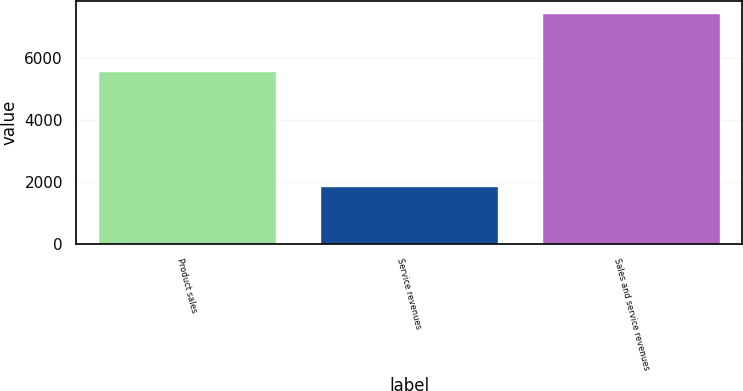<chart> <loc_0><loc_0><loc_500><loc_500><bar_chart><fcel>Product sales<fcel>Service revenues<fcel>Sales and service revenues<nl><fcel>5573<fcel>1868<fcel>7441<nl></chart> 